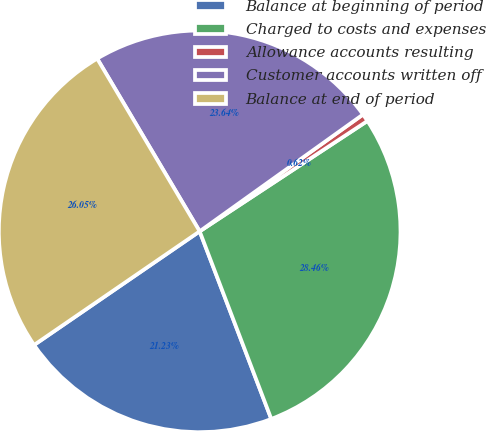<chart> <loc_0><loc_0><loc_500><loc_500><pie_chart><fcel>Balance at beginning of period<fcel>Charged to costs and expenses<fcel>Allowance accounts resulting<fcel>Customer accounts written off<fcel>Balance at end of period<nl><fcel>21.23%<fcel>28.46%<fcel>0.62%<fcel>23.64%<fcel>26.05%<nl></chart> 